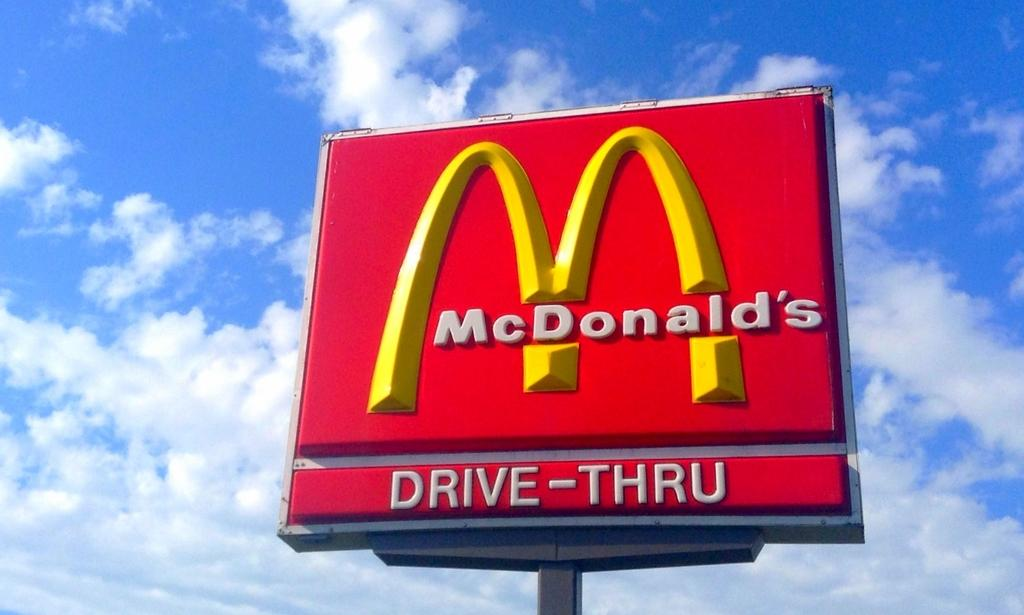<image>
Create a compact narrative representing the image presented. A red McDonald's sign that says drive thru. 